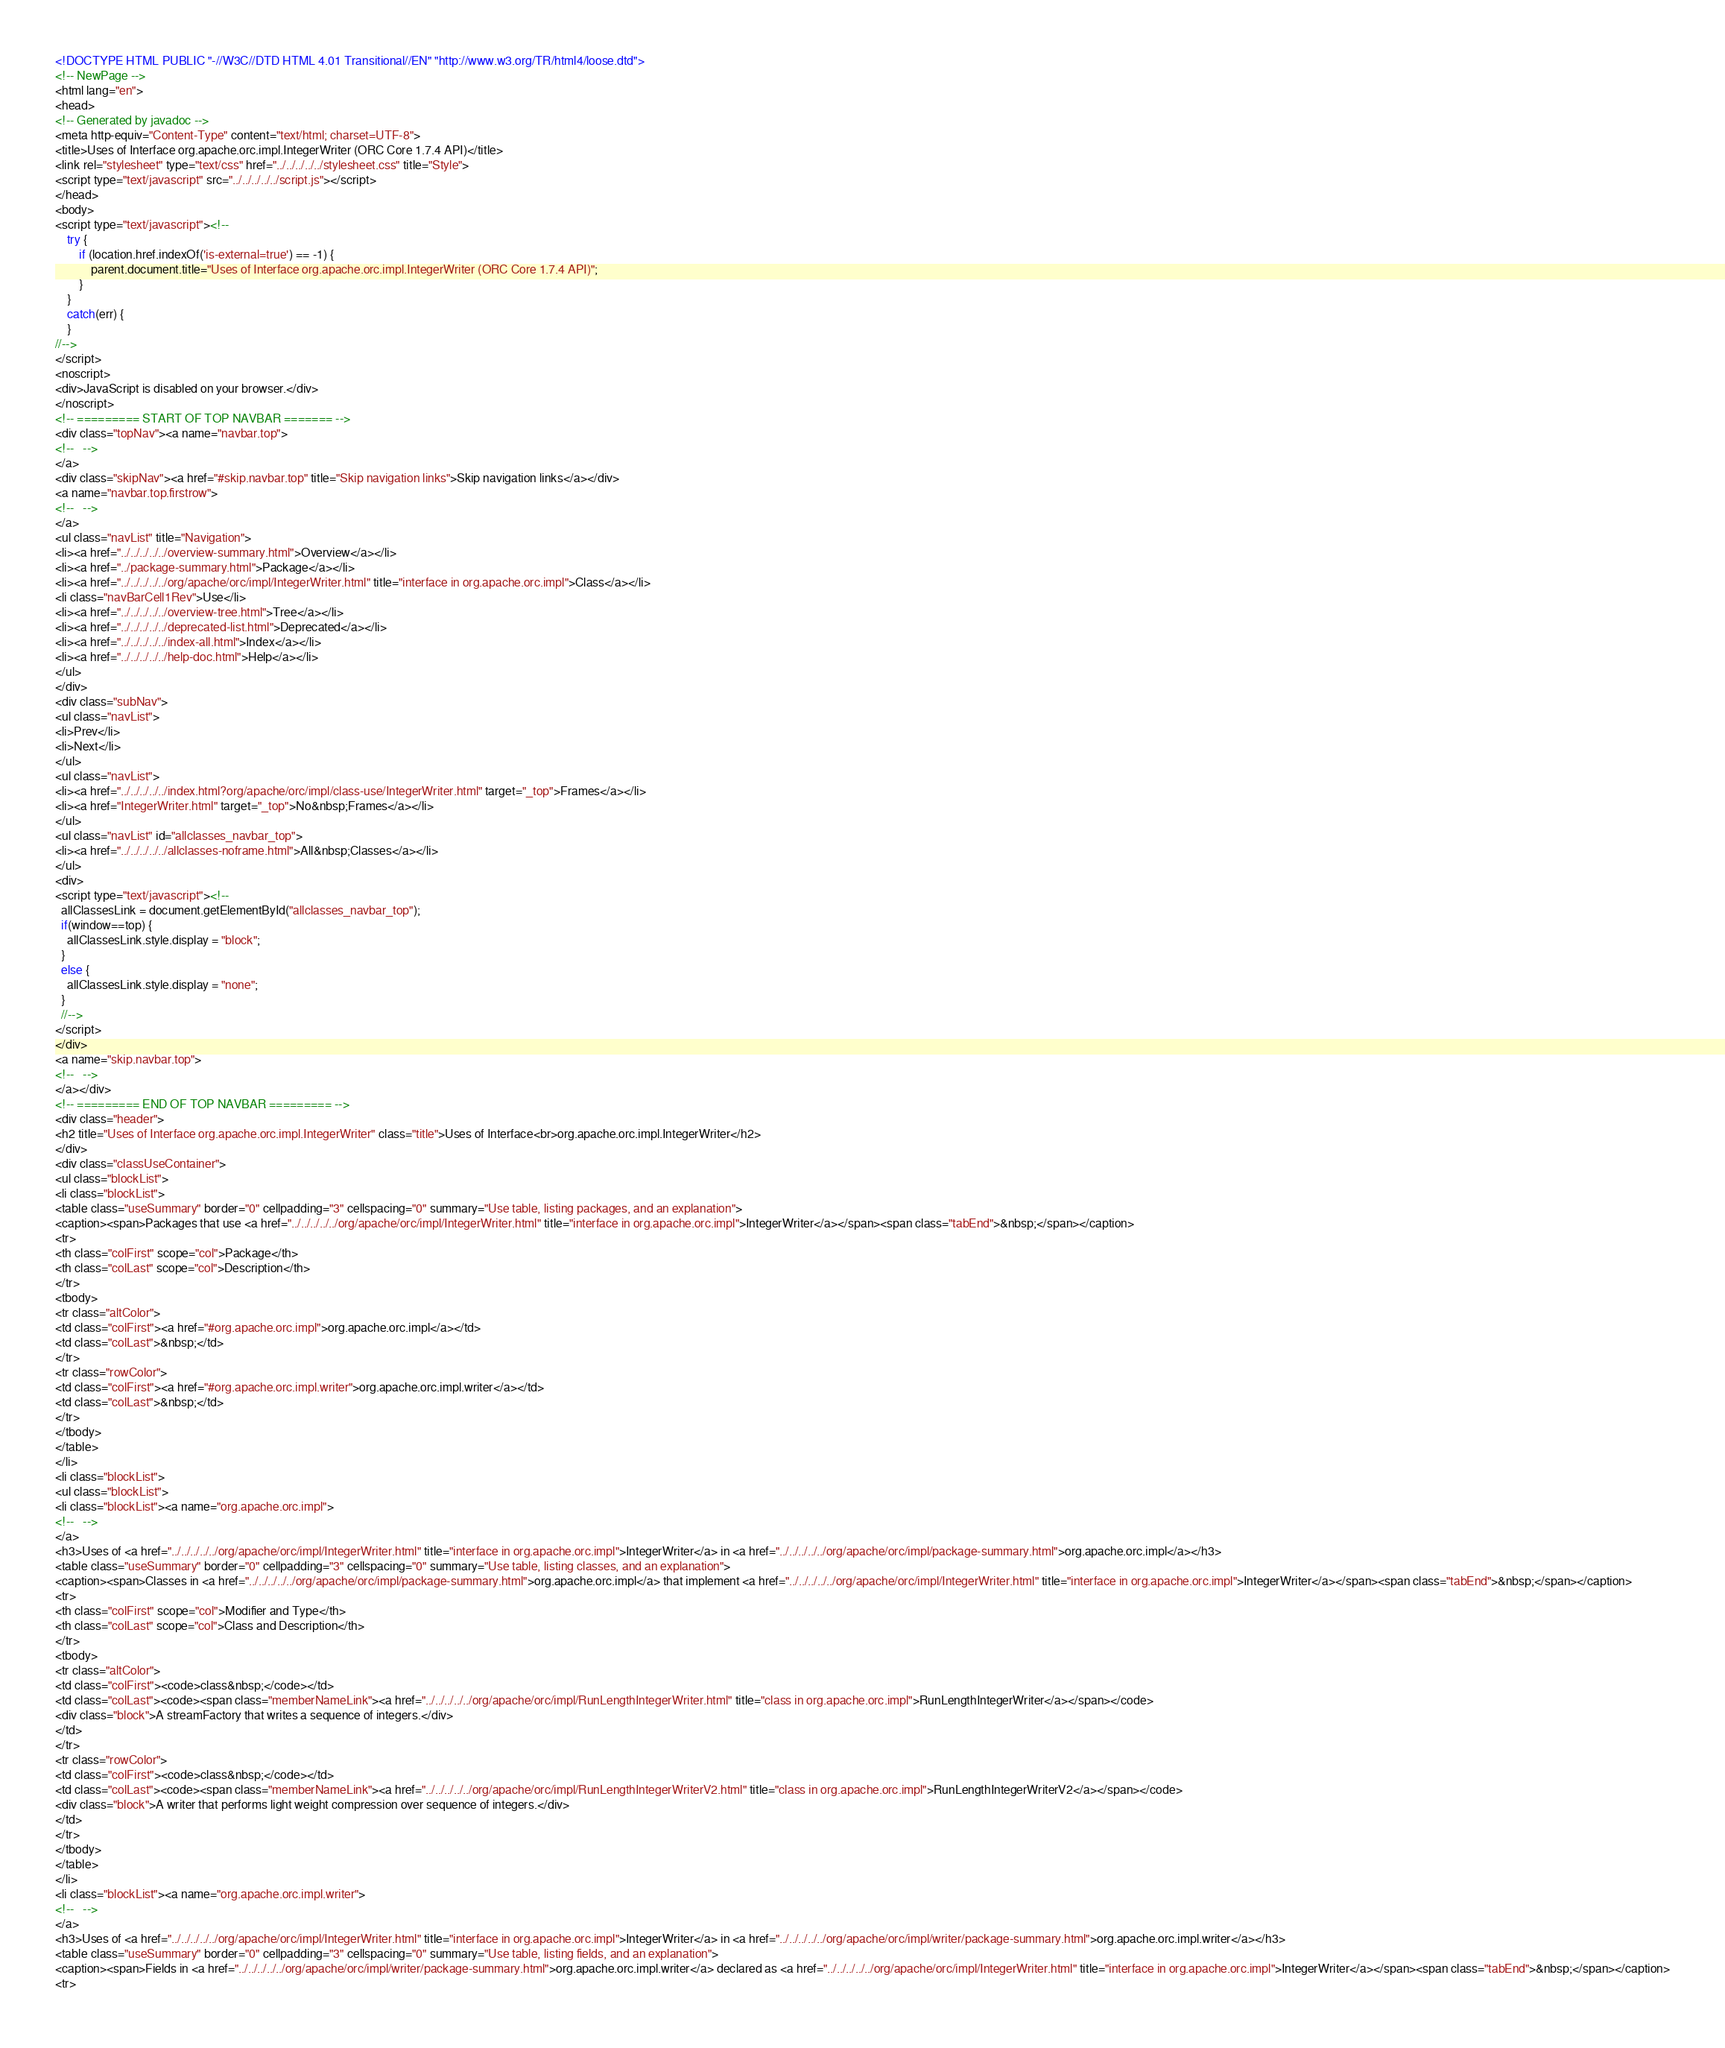<code> <loc_0><loc_0><loc_500><loc_500><_HTML_><!DOCTYPE HTML PUBLIC "-//W3C//DTD HTML 4.01 Transitional//EN" "http://www.w3.org/TR/html4/loose.dtd">
<!-- NewPage -->
<html lang="en">
<head>
<!-- Generated by javadoc -->
<meta http-equiv="Content-Type" content="text/html; charset=UTF-8">
<title>Uses of Interface org.apache.orc.impl.IntegerWriter (ORC Core 1.7.4 API)</title>
<link rel="stylesheet" type="text/css" href="../../../../../stylesheet.css" title="Style">
<script type="text/javascript" src="../../../../../script.js"></script>
</head>
<body>
<script type="text/javascript"><!--
    try {
        if (location.href.indexOf('is-external=true') == -1) {
            parent.document.title="Uses of Interface org.apache.orc.impl.IntegerWriter (ORC Core 1.7.4 API)";
        }
    }
    catch(err) {
    }
//-->
</script>
<noscript>
<div>JavaScript is disabled on your browser.</div>
</noscript>
<!-- ========= START OF TOP NAVBAR ======= -->
<div class="topNav"><a name="navbar.top">
<!--   -->
</a>
<div class="skipNav"><a href="#skip.navbar.top" title="Skip navigation links">Skip navigation links</a></div>
<a name="navbar.top.firstrow">
<!--   -->
</a>
<ul class="navList" title="Navigation">
<li><a href="../../../../../overview-summary.html">Overview</a></li>
<li><a href="../package-summary.html">Package</a></li>
<li><a href="../../../../../org/apache/orc/impl/IntegerWriter.html" title="interface in org.apache.orc.impl">Class</a></li>
<li class="navBarCell1Rev">Use</li>
<li><a href="../../../../../overview-tree.html">Tree</a></li>
<li><a href="../../../../../deprecated-list.html">Deprecated</a></li>
<li><a href="../../../../../index-all.html">Index</a></li>
<li><a href="../../../../../help-doc.html">Help</a></li>
</ul>
</div>
<div class="subNav">
<ul class="navList">
<li>Prev</li>
<li>Next</li>
</ul>
<ul class="navList">
<li><a href="../../../../../index.html?org/apache/orc/impl/class-use/IntegerWriter.html" target="_top">Frames</a></li>
<li><a href="IntegerWriter.html" target="_top">No&nbsp;Frames</a></li>
</ul>
<ul class="navList" id="allclasses_navbar_top">
<li><a href="../../../../../allclasses-noframe.html">All&nbsp;Classes</a></li>
</ul>
<div>
<script type="text/javascript"><!--
  allClassesLink = document.getElementById("allclasses_navbar_top");
  if(window==top) {
    allClassesLink.style.display = "block";
  }
  else {
    allClassesLink.style.display = "none";
  }
  //-->
</script>
</div>
<a name="skip.navbar.top">
<!--   -->
</a></div>
<!-- ========= END OF TOP NAVBAR ========= -->
<div class="header">
<h2 title="Uses of Interface org.apache.orc.impl.IntegerWriter" class="title">Uses of Interface<br>org.apache.orc.impl.IntegerWriter</h2>
</div>
<div class="classUseContainer">
<ul class="blockList">
<li class="blockList">
<table class="useSummary" border="0" cellpadding="3" cellspacing="0" summary="Use table, listing packages, and an explanation">
<caption><span>Packages that use <a href="../../../../../org/apache/orc/impl/IntegerWriter.html" title="interface in org.apache.orc.impl">IntegerWriter</a></span><span class="tabEnd">&nbsp;</span></caption>
<tr>
<th class="colFirst" scope="col">Package</th>
<th class="colLast" scope="col">Description</th>
</tr>
<tbody>
<tr class="altColor">
<td class="colFirst"><a href="#org.apache.orc.impl">org.apache.orc.impl</a></td>
<td class="colLast">&nbsp;</td>
</tr>
<tr class="rowColor">
<td class="colFirst"><a href="#org.apache.orc.impl.writer">org.apache.orc.impl.writer</a></td>
<td class="colLast">&nbsp;</td>
</tr>
</tbody>
</table>
</li>
<li class="blockList">
<ul class="blockList">
<li class="blockList"><a name="org.apache.orc.impl">
<!--   -->
</a>
<h3>Uses of <a href="../../../../../org/apache/orc/impl/IntegerWriter.html" title="interface in org.apache.orc.impl">IntegerWriter</a> in <a href="../../../../../org/apache/orc/impl/package-summary.html">org.apache.orc.impl</a></h3>
<table class="useSummary" border="0" cellpadding="3" cellspacing="0" summary="Use table, listing classes, and an explanation">
<caption><span>Classes in <a href="../../../../../org/apache/orc/impl/package-summary.html">org.apache.orc.impl</a> that implement <a href="../../../../../org/apache/orc/impl/IntegerWriter.html" title="interface in org.apache.orc.impl">IntegerWriter</a></span><span class="tabEnd">&nbsp;</span></caption>
<tr>
<th class="colFirst" scope="col">Modifier and Type</th>
<th class="colLast" scope="col">Class and Description</th>
</tr>
<tbody>
<tr class="altColor">
<td class="colFirst"><code>class&nbsp;</code></td>
<td class="colLast"><code><span class="memberNameLink"><a href="../../../../../org/apache/orc/impl/RunLengthIntegerWriter.html" title="class in org.apache.orc.impl">RunLengthIntegerWriter</a></span></code>
<div class="block">A streamFactory that writes a sequence of integers.</div>
</td>
</tr>
<tr class="rowColor">
<td class="colFirst"><code>class&nbsp;</code></td>
<td class="colLast"><code><span class="memberNameLink"><a href="../../../../../org/apache/orc/impl/RunLengthIntegerWriterV2.html" title="class in org.apache.orc.impl">RunLengthIntegerWriterV2</a></span></code>
<div class="block">A writer that performs light weight compression over sequence of integers.</div>
</td>
</tr>
</tbody>
</table>
</li>
<li class="blockList"><a name="org.apache.orc.impl.writer">
<!--   -->
</a>
<h3>Uses of <a href="../../../../../org/apache/orc/impl/IntegerWriter.html" title="interface in org.apache.orc.impl">IntegerWriter</a> in <a href="../../../../../org/apache/orc/impl/writer/package-summary.html">org.apache.orc.impl.writer</a></h3>
<table class="useSummary" border="0" cellpadding="3" cellspacing="0" summary="Use table, listing fields, and an explanation">
<caption><span>Fields in <a href="../../../../../org/apache/orc/impl/writer/package-summary.html">org.apache.orc.impl.writer</a> declared as <a href="../../../../../org/apache/orc/impl/IntegerWriter.html" title="interface in org.apache.orc.impl">IntegerWriter</a></span><span class="tabEnd">&nbsp;</span></caption>
<tr></code> 